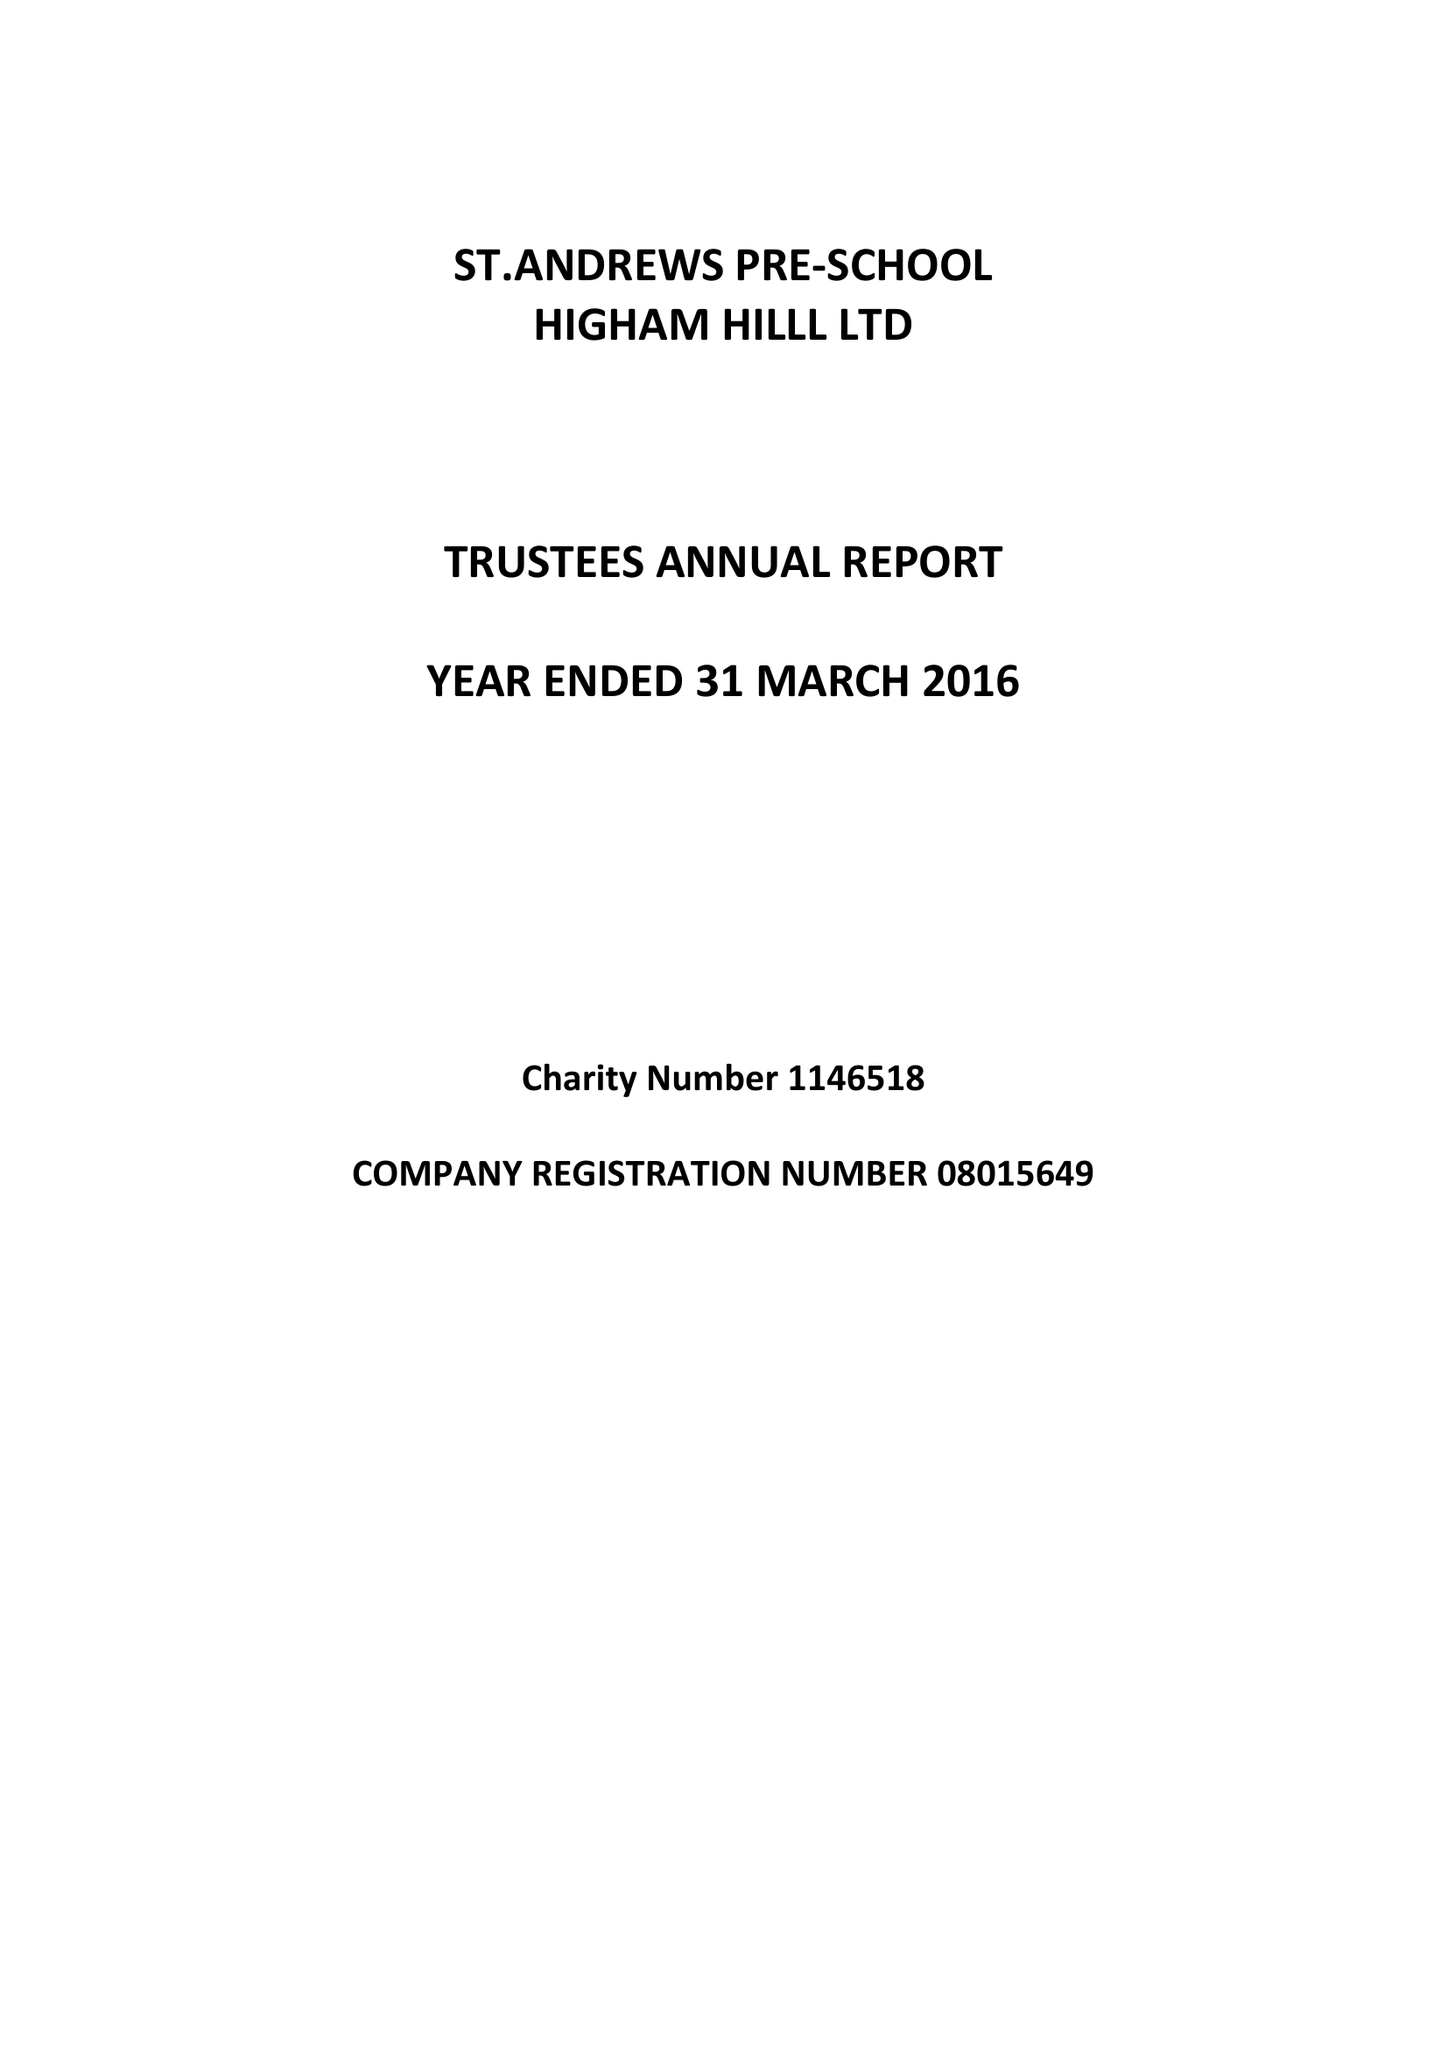What is the value for the income_annually_in_british_pounds?
Answer the question using a single word or phrase. 102756.00 